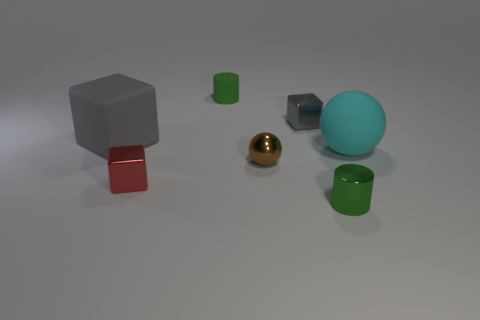Are there any two objects in the image that are similar in shape but different in size? Yes, there are two cubes in the image that are similar in shape but different in size. The larger cube is gray, and the smaller cube has blue and gray colors. Could you describe the setting in which these objects are placed? The objects are arranged on a flat, neutral surface that gives the impression of a controlled environment, likely set up for display or for an artistic composition. The background is nondescript, with soft shadows suggesting a diffuse and ambient light source. 